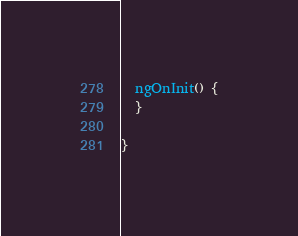Convert code to text. <code><loc_0><loc_0><loc_500><loc_500><_TypeScript_>  ngOnInit() {
  }

}
</code> 